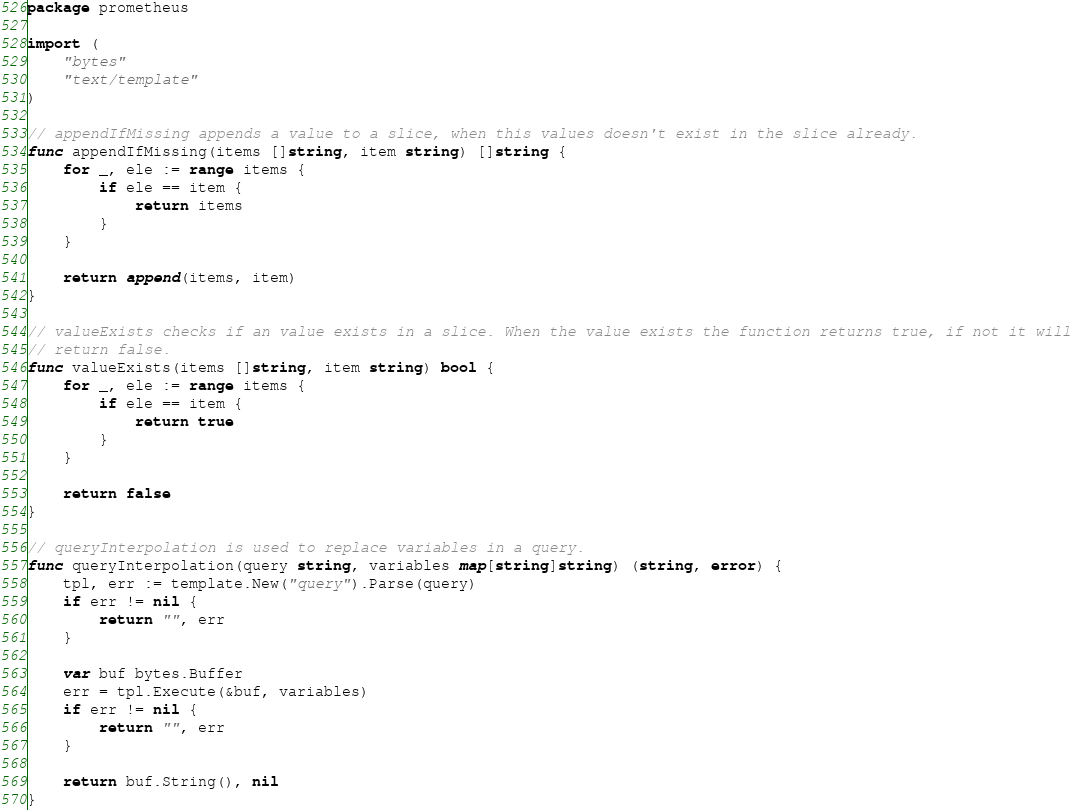Convert code to text. <code><loc_0><loc_0><loc_500><loc_500><_Go_>package prometheus

import (
	"bytes"
	"text/template"
)

// appendIfMissing appends a value to a slice, when this values doesn't exist in the slice already.
func appendIfMissing(items []string, item string) []string {
	for _, ele := range items {
		if ele == item {
			return items
		}
	}

	return append(items, item)
}

// valueExists checks if an value exists in a slice. When the value exists the function returns true, if not it will
// return false.
func valueExists(items []string, item string) bool {
	for _, ele := range items {
		if ele == item {
			return true
		}
	}

	return false
}

// queryInterpolation is used to replace variables in a query.
func queryInterpolation(query string, variables map[string]string) (string, error) {
	tpl, err := template.New("query").Parse(query)
	if err != nil {
		return "", err
	}

	var buf bytes.Buffer
	err = tpl.Execute(&buf, variables)
	if err != nil {
		return "", err
	}

	return buf.String(), nil
}
</code> 